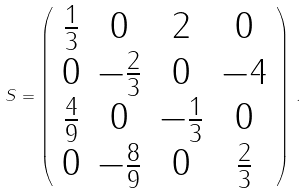Convert formula to latex. <formula><loc_0><loc_0><loc_500><loc_500>S = \left ( \begin{array} { c c c c } { { \frac { 1 } { 3 } } } & { 0 } & { 2 } & { 0 } \\ { 0 } & { { - \frac { 2 } { 3 } } } & { 0 } & { - 4 } \\ { { \frac { 4 } { 9 } } } & { 0 } & { { - \frac { 1 } { 3 } } } & { 0 } \\ { 0 } & { { - \frac { 8 } { 9 } } } & { 0 } & { { \frac { 2 } { 3 } } } \end{array} \right ) \, .</formula> 